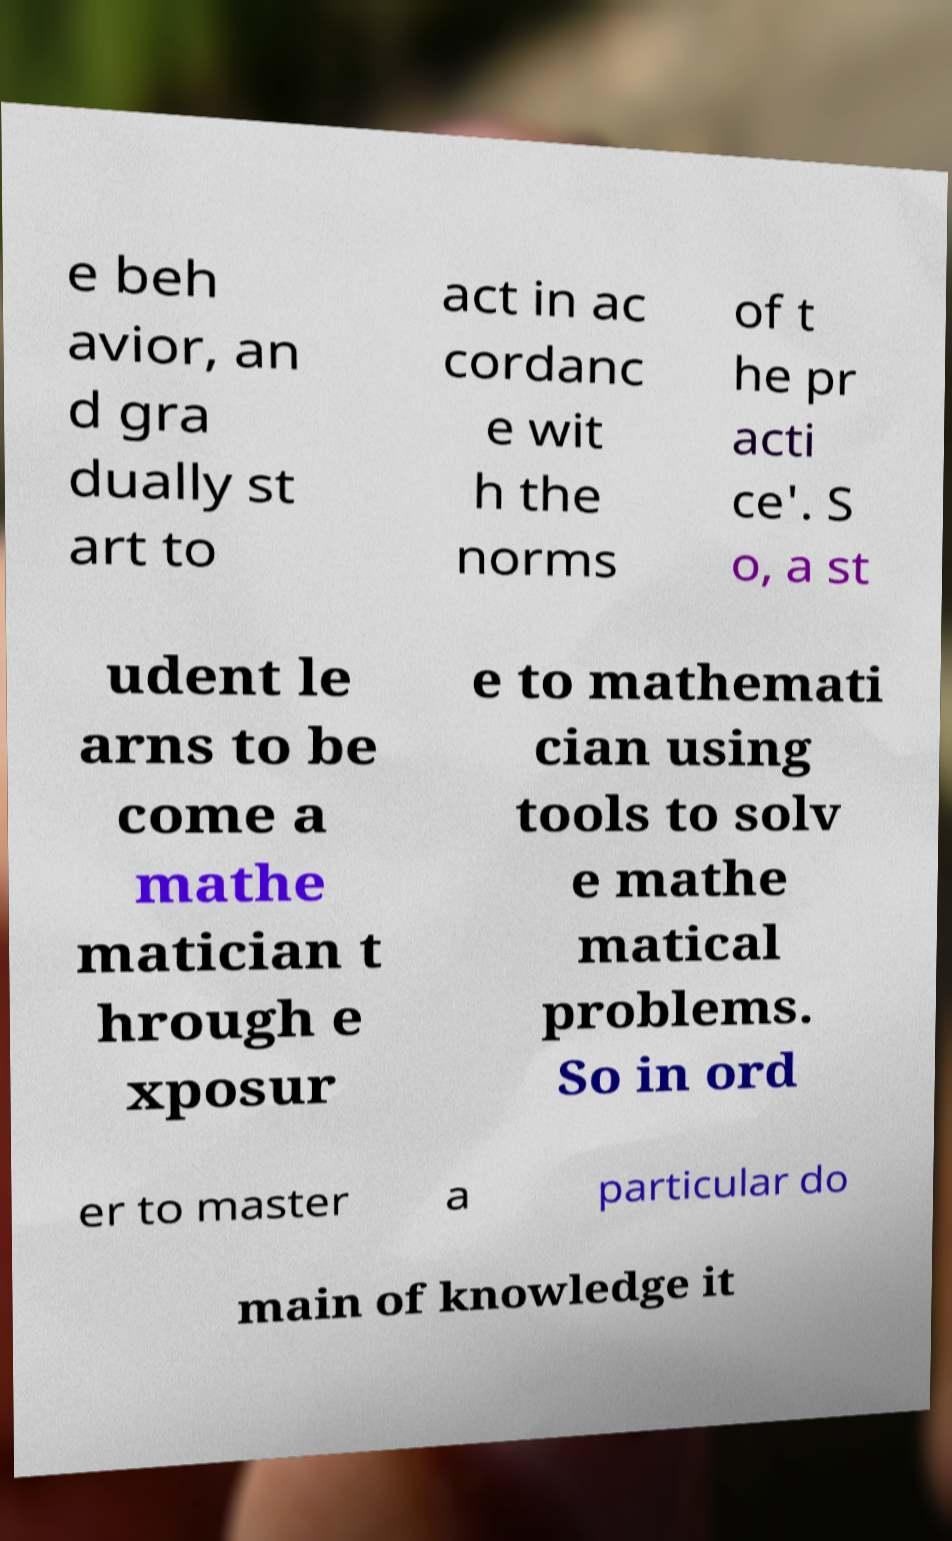Could you assist in decoding the text presented in this image and type it out clearly? e beh avior, an d gra dually st art to act in ac cordanc e wit h the norms of t he pr acti ce'. S o, a st udent le arns to be come a mathe matician t hrough e xposur e to mathemati cian using tools to solv e mathe matical problems. So in ord er to master a particular do main of knowledge it 